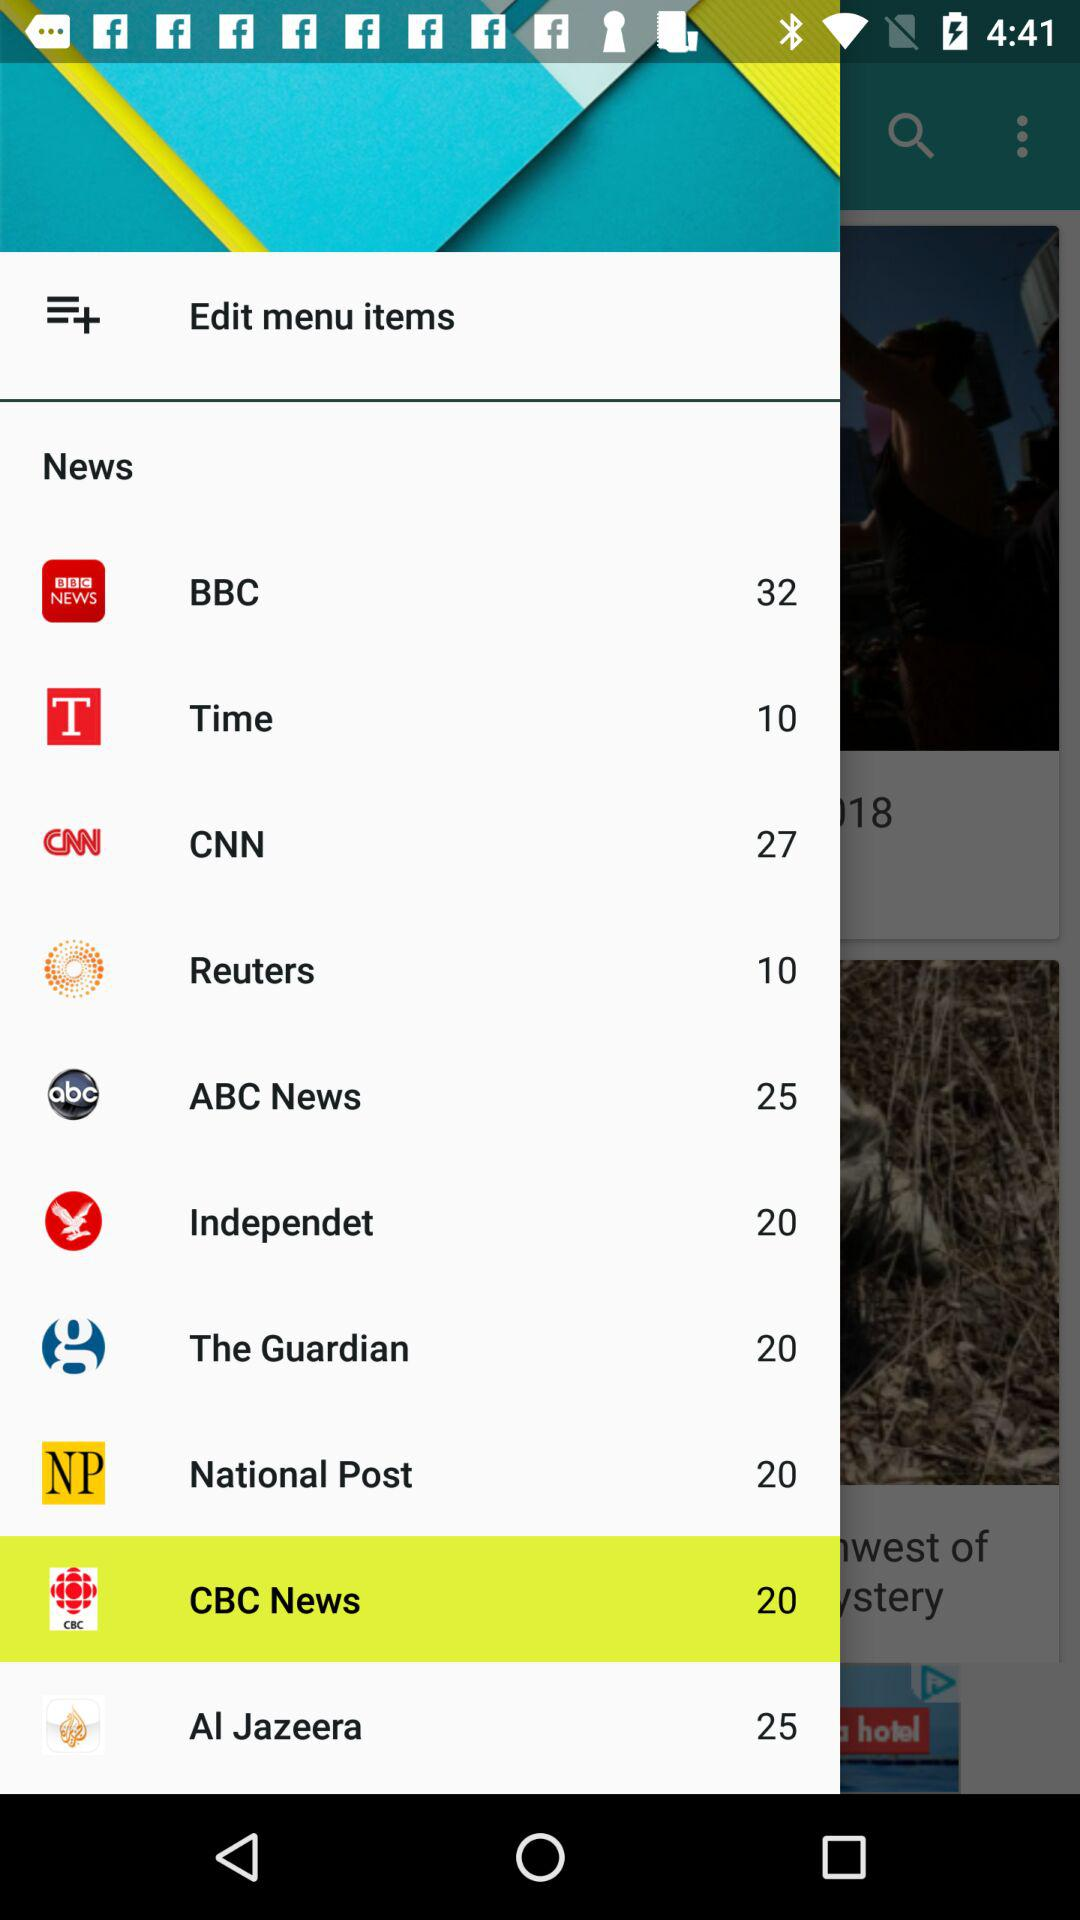How much news is on ABC News? There are 25 news on ABC news. 